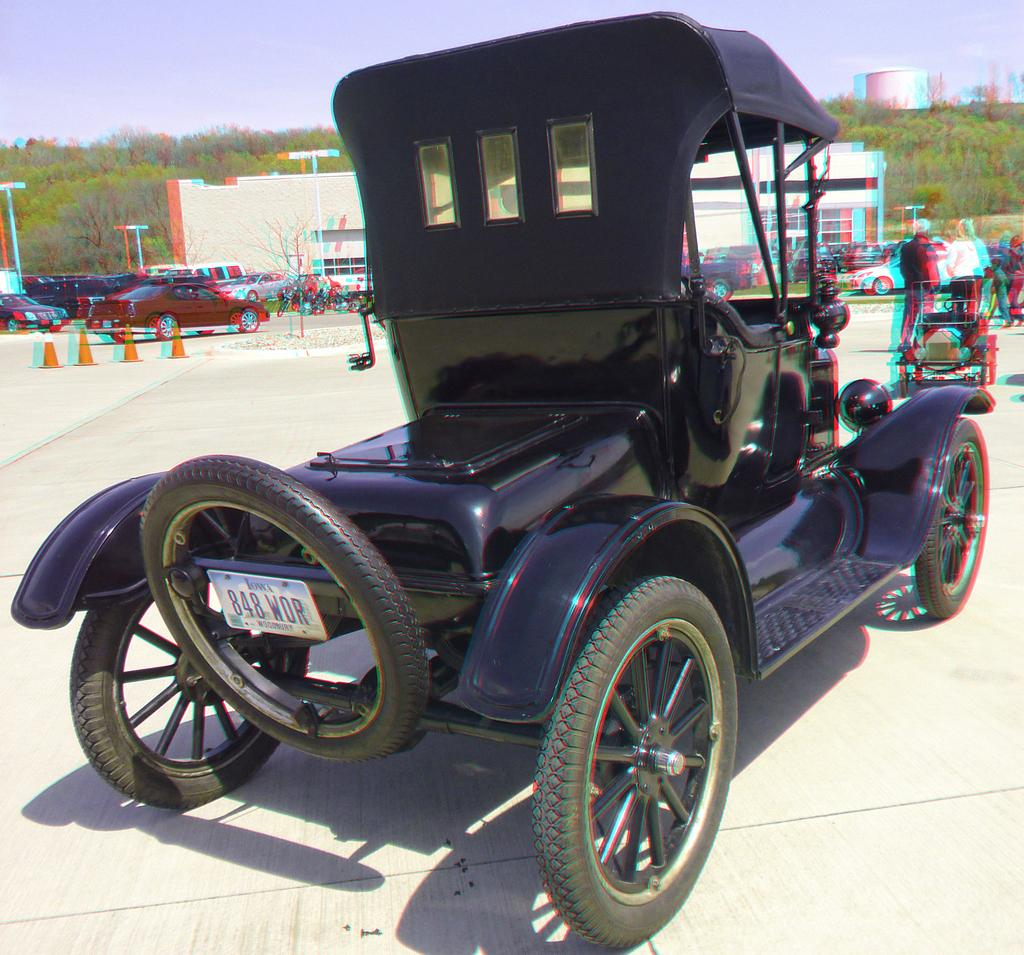What is the color of the vehicle in the image? There is a black color vehicle in the image. Where are the people located in the image? The people are standing in the right corner of the image. What can be seen in the background of the image? There are other vehicles, buildings, and trees in the background of the image. What type of marble is present in the image? There is no marble present in the image. What does the image smell like? The image does not have a smell, as it is a visual representation. 